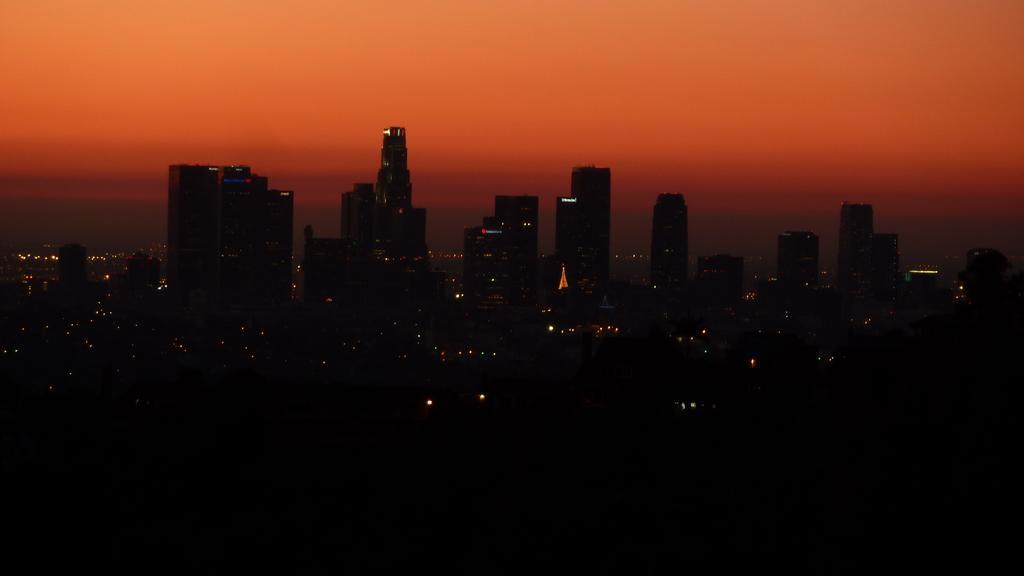How would you summarize this image in a sentence or two? In this image, we can see some buildings. There is a sky at the top of the image. 